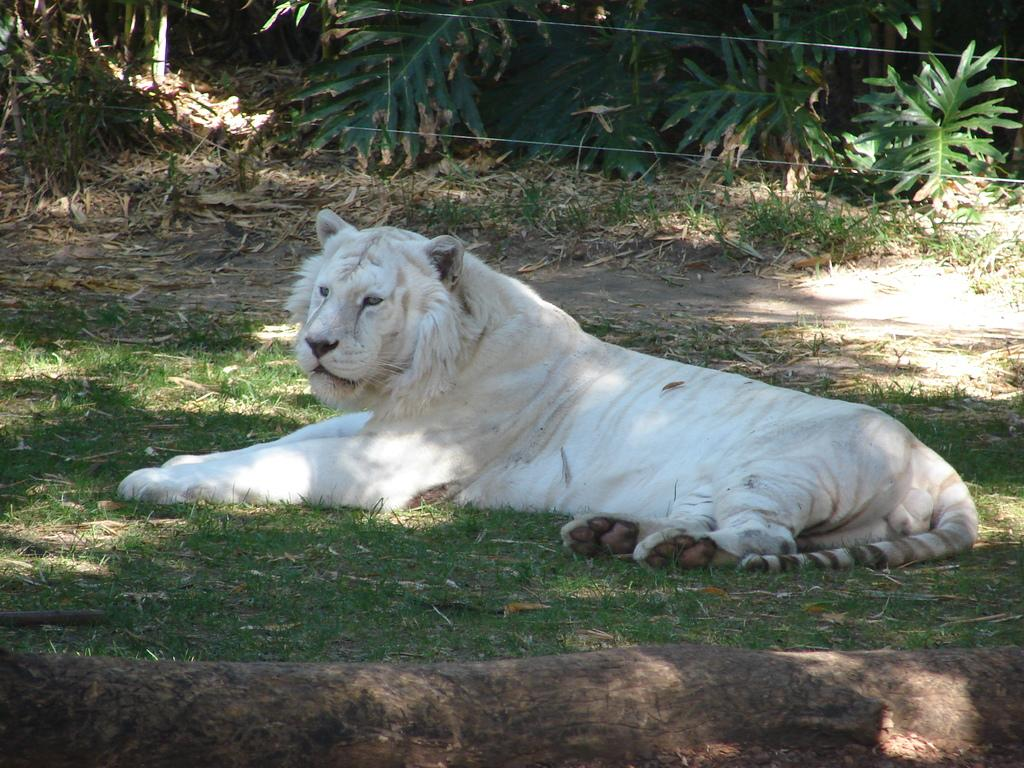What animal is on the ground in the image? There is a tiger on the ground in the image. What can be seen in the background of the image? There are plants and cables in the background of the image. What is present at the bottom of the image? Wood logs and grass are visible at the bottom of the image. What time of day is it in the image, based on the presence of mist? There is no mist present in the image, so it is not possible to determine the time of day based on that factor. 